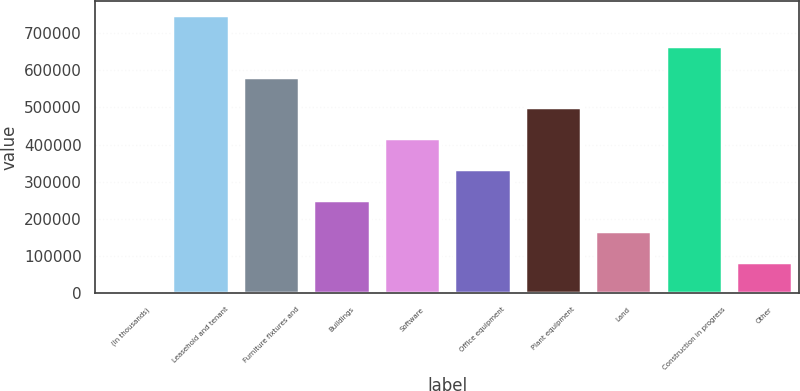<chart> <loc_0><loc_0><loc_500><loc_500><bar_chart><fcel>(In thousands)<fcel>Leasehold and tenant<fcel>Furniture fixtures and<fcel>Buildings<fcel>Software<fcel>Office equipment<fcel>Plant equipment<fcel>Land<fcel>Construction in progress<fcel>Other<nl><fcel>2015<fcel>748789<fcel>582839<fcel>250940<fcel>416890<fcel>333915<fcel>499864<fcel>167965<fcel>665814<fcel>84989.9<nl></chart> 